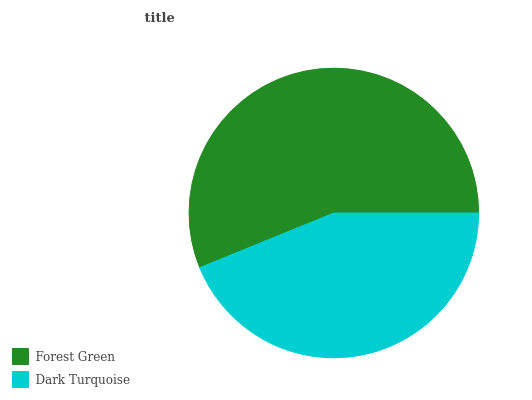Is Dark Turquoise the minimum?
Answer yes or no. Yes. Is Forest Green the maximum?
Answer yes or no. Yes. Is Dark Turquoise the maximum?
Answer yes or no. No. Is Forest Green greater than Dark Turquoise?
Answer yes or no. Yes. Is Dark Turquoise less than Forest Green?
Answer yes or no. Yes. Is Dark Turquoise greater than Forest Green?
Answer yes or no. No. Is Forest Green less than Dark Turquoise?
Answer yes or no. No. Is Forest Green the high median?
Answer yes or no. Yes. Is Dark Turquoise the low median?
Answer yes or no. Yes. Is Dark Turquoise the high median?
Answer yes or no. No. Is Forest Green the low median?
Answer yes or no. No. 